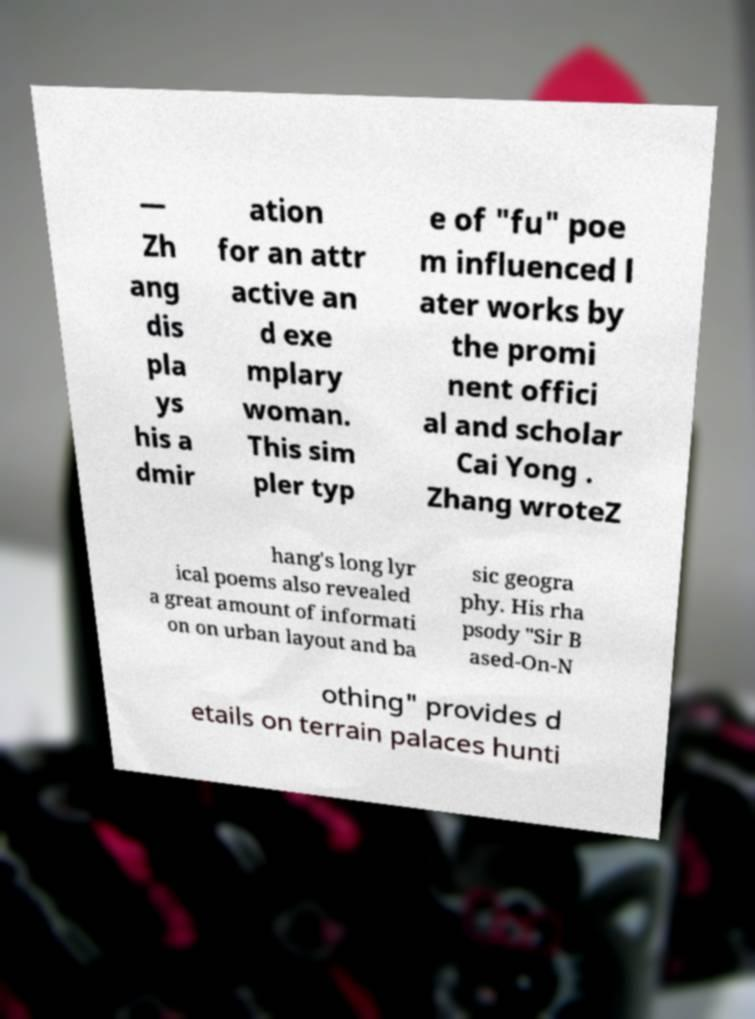What messages or text are displayed in this image? I need them in a readable, typed format. — Zh ang dis pla ys his a dmir ation for an attr active an d exe mplary woman. This sim pler typ e of "fu" poe m influenced l ater works by the promi nent offici al and scholar Cai Yong . Zhang wroteZ hang's long lyr ical poems also revealed a great amount of informati on on urban layout and ba sic geogra phy. His rha psody "Sir B ased-On-N othing" provides d etails on terrain palaces hunti 